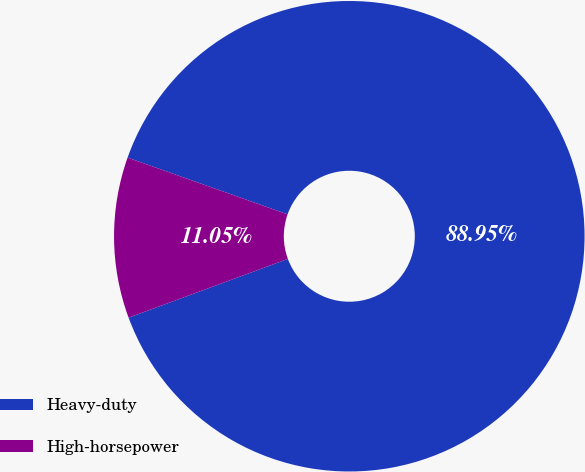Convert chart. <chart><loc_0><loc_0><loc_500><loc_500><pie_chart><fcel>Heavy-duty<fcel>High-horsepower<nl><fcel>88.95%<fcel>11.05%<nl></chart> 